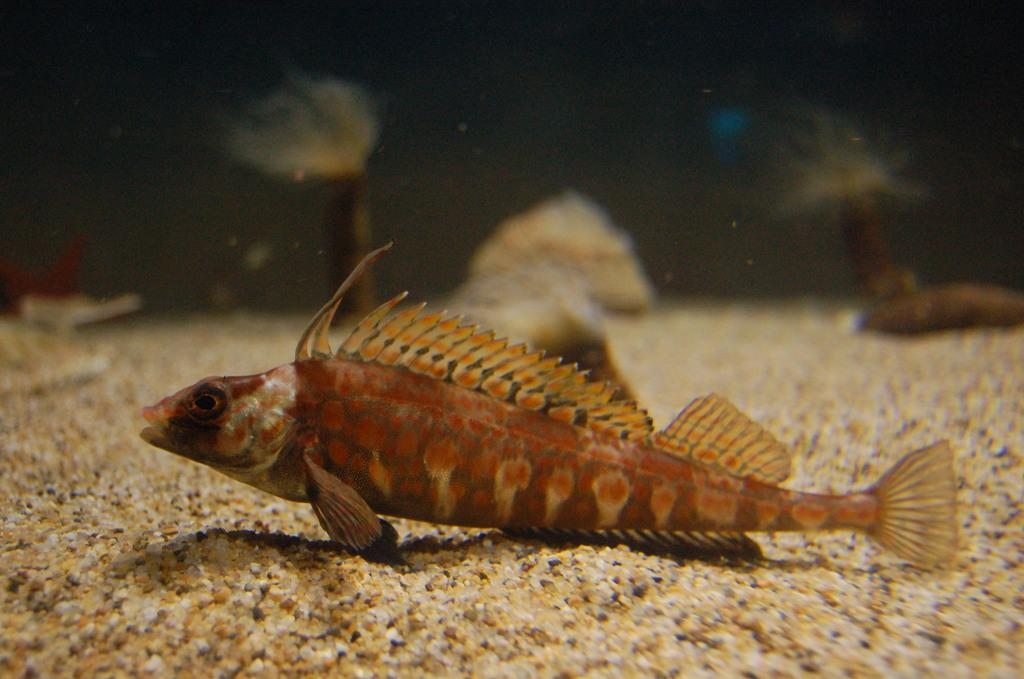Where was the image taken? The image was taken underwater. What can be seen in the image? There is a fish in the image, and there are marine species present. In which direction is the fish facing? The fish is facing towards the left side. What type of humor is the fish displaying in the image? There is no indication of humor in the image, as it is a photograph of a fish underwater. 